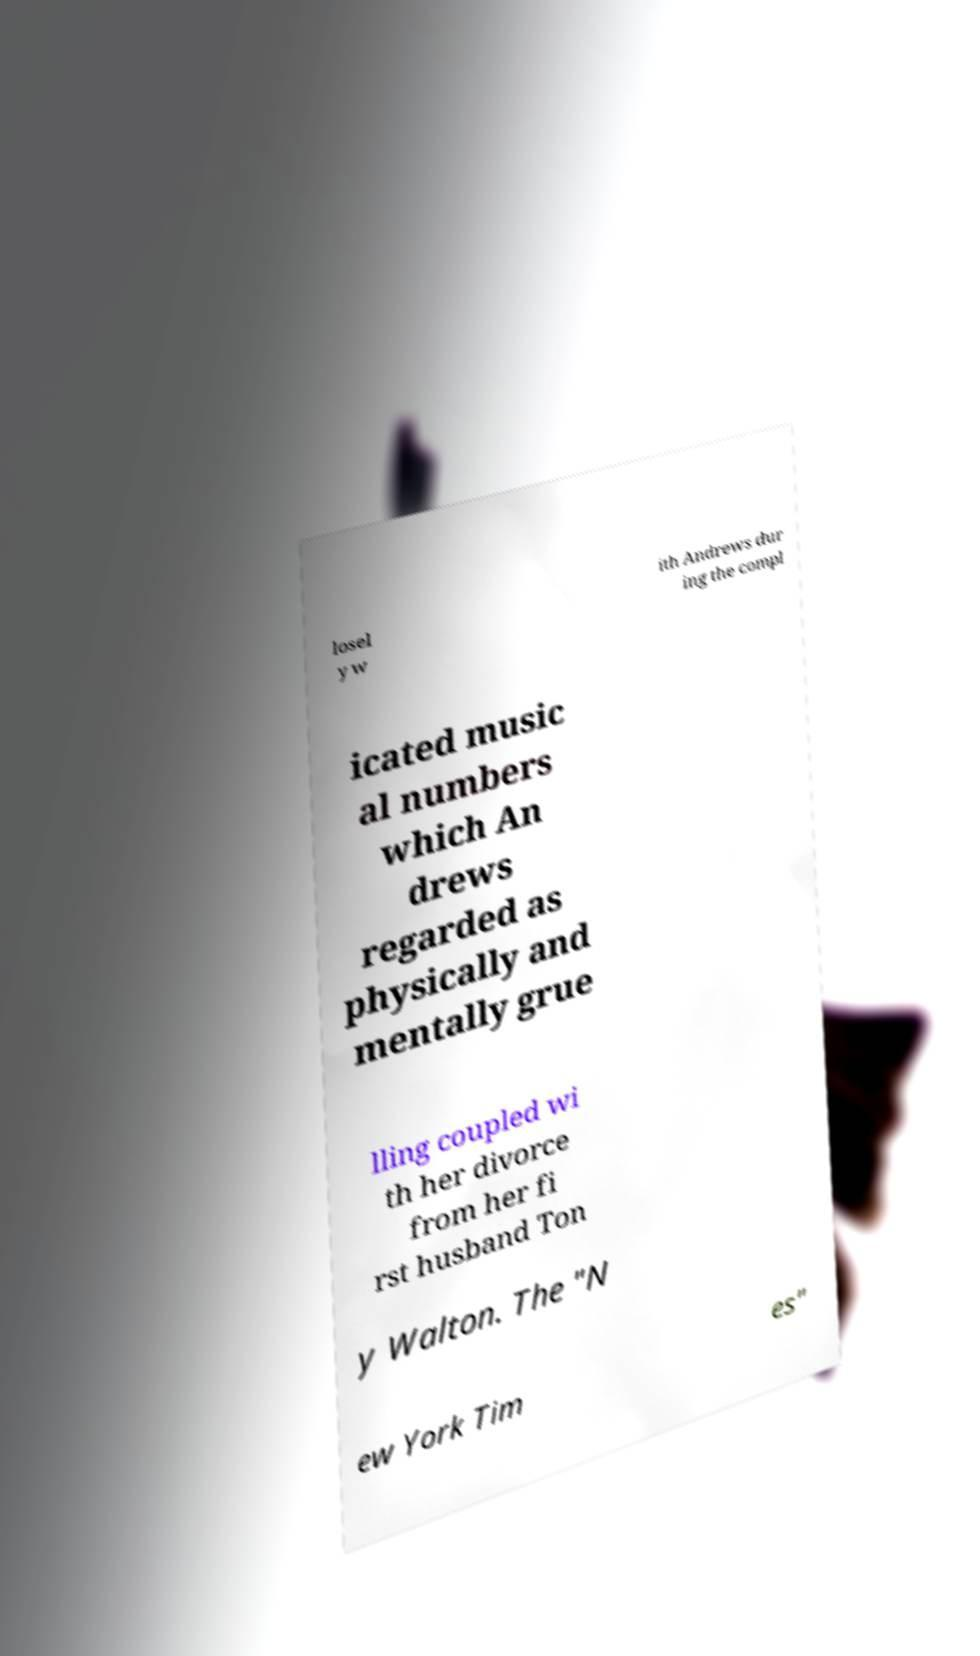Could you extract and type out the text from this image? losel y w ith Andrews dur ing the compl icated music al numbers which An drews regarded as physically and mentally grue lling coupled wi th her divorce from her fi rst husband Ton y Walton. The "N ew York Tim es" 